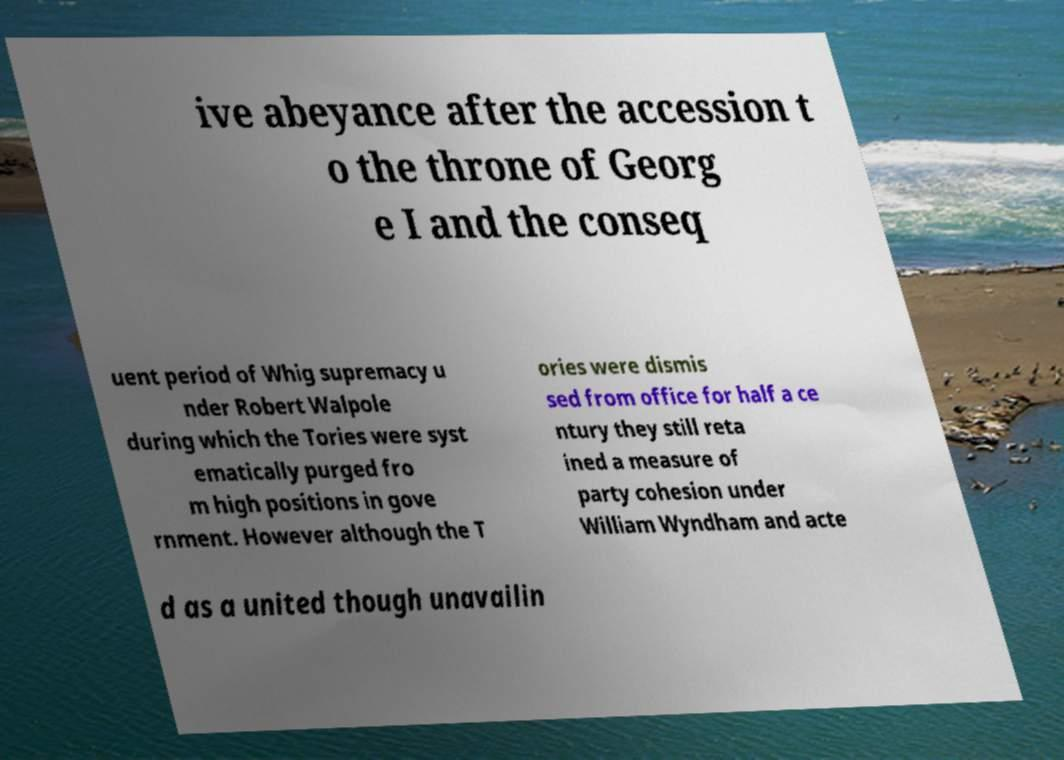Can you read and provide the text displayed in the image?This photo seems to have some interesting text. Can you extract and type it out for me? ive abeyance after the accession t o the throne of Georg e I and the conseq uent period of Whig supremacy u nder Robert Walpole during which the Tories were syst ematically purged fro m high positions in gove rnment. However although the T ories were dismis sed from office for half a ce ntury they still reta ined a measure of party cohesion under William Wyndham and acte d as a united though unavailin 